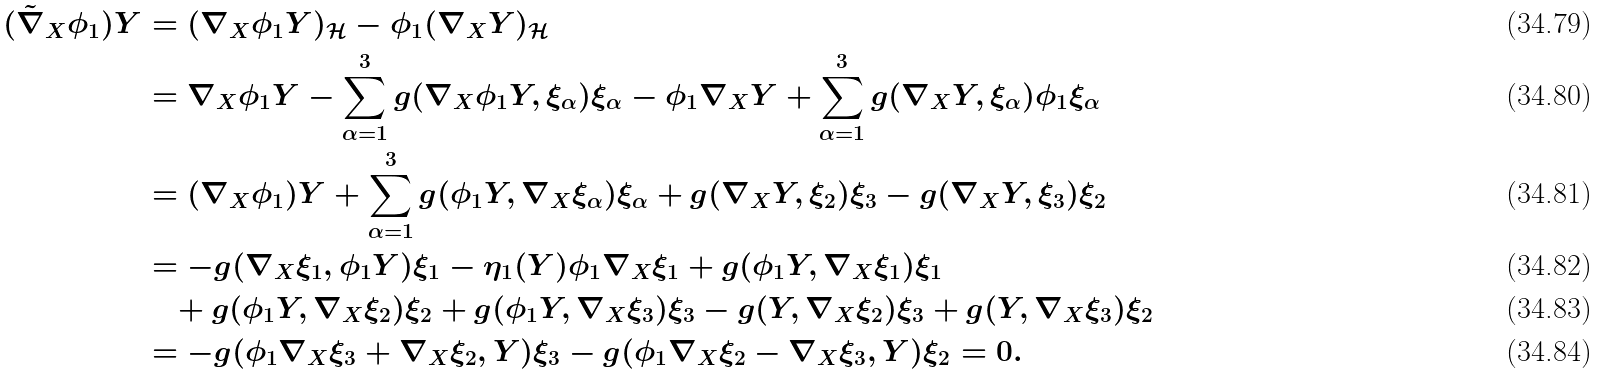<formula> <loc_0><loc_0><loc_500><loc_500>( \tilde { \nabla } _ { X } \phi _ { 1 } ) Y & = ( \nabla _ { X } \phi _ { 1 } Y ) _ { \mathcal { H } } - \phi _ { 1 } ( \nabla _ { X } Y ) _ { \mathcal { H } } \\ & = \nabla _ { X } \phi _ { 1 } Y - \sum _ { \alpha = 1 } ^ { 3 } g ( \nabla _ { X } \phi _ { 1 } Y , \xi _ { \alpha } ) \xi _ { \alpha } - \phi _ { 1 } \nabla _ { X } Y + \sum _ { \alpha = 1 } ^ { 3 } g ( \nabla _ { X } Y , \xi _ { \alpha } ) \phi _ { 1 } \xi _ { \alpha } \\ & = ( \nabla _ { X } \phi _ { 1 } ) Y + \sum _ { \alpha = 1 } ^ { 3 } g ( \phi _ { 1 } Y , \nabla _ { X } \xi _ { \alpha } ) \xi _ { \alpha } + g ( \nabla _ { X } Y , \xi _ { 2 } ) \xi _ { 3 } - g ( \nabla _ { X } Y , \xi _ { 3 } ) \xi _ { 2 } \\ & = - g ( \nabla _ { X } \xi _ { 1 } , \phi _ { 1 } Y ) \xi _ { 1 } - \eta _ { 1 } ( Y ) \phi _ { 1 } \nabla _ { X } \xi _ { 1 } + g ( \phi _ { 1 } Y , \nabla _ { X } \xi _ { 1 } ) \xi _ { 1 } \\ & \quad + g ( \phi _ { 1 } Y , \nabla _ { X } \xi _ { 2 } ) \xi _ { 2 } + g ( \phi _ { 1 } Y , \nabla _ { X } \xi _ { 3 } ) \xi _ { 3 } - g ( Y , \nabla _ { X } \xi _ { 2 } ) \xi _ { 3 } + g ( Y , \nabla _ { X } \xi _ { 3 } ) \xi _ { 2 } \\ & = - g ( \phi _ { 1 } \nabla _ { X } \xi _ { 3 } + \nabla _ { X } \xi _ { 2 } , Y ) \xi _ { 3 } - g ( \phi _ { 1 } \nabla _ { X } \xi _ { 2 } - \nabla _ { X } \xi _ { 3 } , Y ) \xi _ { 2 } = 0 .</formula> 